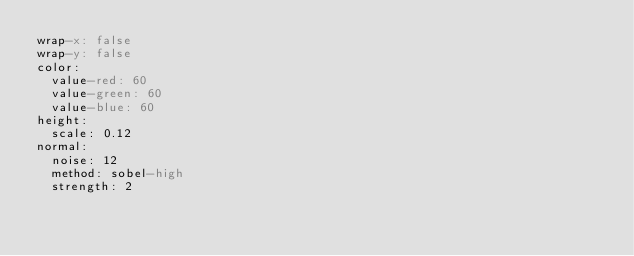<code> <loc_0><loc_0><loc_500><loc_500><_YAML_>wrap-x: false
wrap-y: false
color:
  value-red: 60
  value-green: 60
  value-blue: 60
height:
  scale: 0.12
normal:
  noise: 12
  method: sobel-high
  strength: 2
</code> 